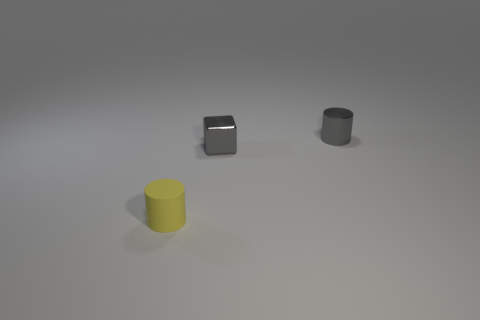Add 2 yellow rubber things. How many objects exist? 5 Subtract all cylinders. How many objects are left? 1 Subtract all tiny yellow cubes. Subtract all tiny gray shiny cubes. How many objects are left? 2 Add 3 small cylinders. How many small cylinders are left? 5 Add 1 big purple blocks. How many big purple blocks exist? 1 Subtract 0 cyan balls. How many objects are left? 3 